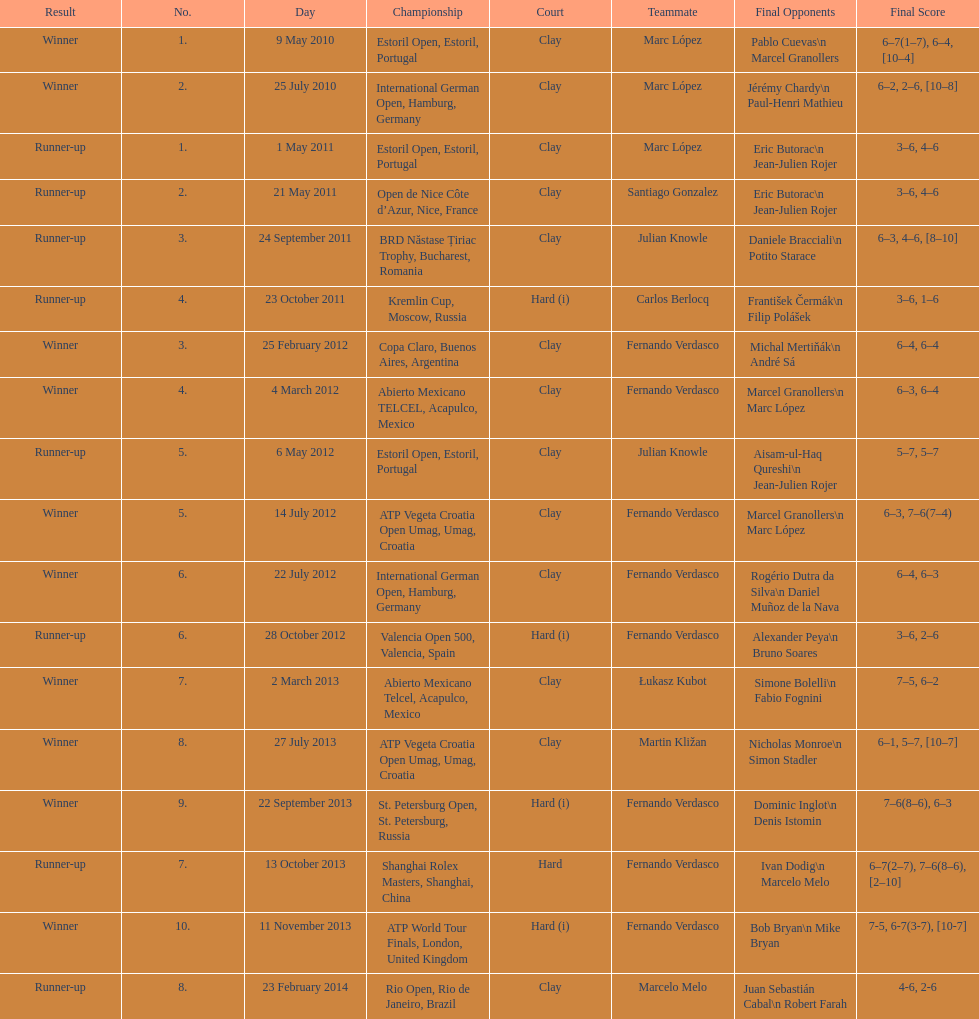How many runner-ups at most are listed? 8. Would you be able to parse every entry in this table? {'header': ['Result', 'No.', 'Day', 'Championship', 'Court', 'Teammate', 'Final Opponents', 'Final Score'], 'rows': [['Winner', '1.', '9 May 2010', 'Estoril Open, Estoril, Portugal', 'Clay', 'Marc López', 'Pablo Cuevas\\n Marcel Granollers', '6–7(1–7), 6–4, [10–4]'], ['Winner', '2.', '25 July 2010', 'International German Open, Hamburg, Germany', 'Clay', 'Marc López', 'Jérémy Chardy\\n Paul-Henri Mathieu', '6–2, 2–6, [10–8]'], ['Runner-up', '1.', '1 May 2011', 'Estoril Open, Estoril, Portugal', 'Clay', 'Marc López', 'Eric Butorac\\n Jean-Julien Rojer', '3–6, 4–6'], ['Runner-up', '2.', '21 May 2011', 'Open de Nice Côte d’Azur, Nice, France', 'Clay', 'Santiago Gonzalez', 'Eric Butorac\\n Jean-Julien Rojer', '3–6, 4–6'], ['Runner-up', '3.', '24 September 2011', 'BRD Năstase Țiriac Trophy, Bucharest, Romania', 'Clay', 'Julian Knowle', 'Daniele Bracciali\\n Potito Starace', '6–3, 4–6, [8–10]'], ['Runner-up', '4.', '23 October 2011', 'Kremlin Cup, Moscow, Russia', 'Hard (i)', 'Carlos Berlocq', 'František Čermák\\n Filip Polášek', '3–6, 1–6'], ['Winner', '3.', '25 February 2012', 'Copa Claro, Buenos Aires, Argentina', 'Clay', 'Fernando Verdasco', 'Michal Mertiňák\\n André Sá', '6–4, 6–4'], ['Winner', '4.', '4 March 2012', 'Abierto Mexicano TELCEL, Acapulco, Mexico', 'Clay', 'Fernando Verdasco', 'Marcel Granollers\\n Marc López', '6–3, 6–4'], ['Runner-up', '5.', '6 May 2012', 'Estoril Open, Estoril, Portugal', 'Clay', 'Julian Knowle', 'Aisam-ul-Haq Qureshi\\n Jean-Julien Rojer', '5–7, 5–7'], ['Winner', '5.', '14 July 2012', 'ATP Vegeta Croatia Open Umag, Umag, Croatia', 'Clay', 'Fernando Verdasco', 'Marcel Granollers\\n Marc López', '6–3, 7–6(7–4)'], ['Winner', '6.', '22 July 2012', 'International German Open, Hamburg, Germany', 'Clay', 'Fernando Verdasco', 'Rogério Dutra da Silva\\n Daniel Muñoz de la Nava', '6–4, 6–3'], ['Runner-up', '6.', '28 October 2012', 'Valencia Open 500, Valencia, Spain', 'Hard (i)', 'Fernando Verdasco', 'Alexander Peya\\n Bruno Soares', '3–6, 2–6'], ['Winner', '7.', '2 March 2013', 'Abierto Mexicano Telcel, Acapulco, Mexico', 'Clay', 'Łukasz Kubot', 'Simone Bolelli\\n Fabio Fognini', '7–5, 6–2'], ['Winner', '8.', '27 July 2013', 'ATP Vegeta Croatia Open Umag, Umag, Croatia', 'Clay', 'Martin Kližan', 'Nicholas Monroe\\n Simon Stadler', '6–1, 5–7, [10–7]'], ['Winner', '9.', '22 September 2013', 'St. Petersburg Open, St. Petersburg, Russia', 'Hard (i)', 'Fernando Verdasco', 'Dominic Inglot\\n Denis Istomin', '7–6(8–6), 6–3'], ['Runner-up', '7.', '13 October 2013', 'Shanghai Rolex Masters, Shanghai, China', 'Hard', 'Fernando Verdasco', 'Ivan Dodig\\n Marcelo Melo', '6–7(2–7), 7–6(8–6), [2–10]'], ['Winner', '10.', '11 November 2013', 'ATP World Tour Finals, London, United Kingdom', 'Hard (i)', 'Fernando Verdasco', 'Bob Bryan\\n Mike Bryan', '7-5, 6-7(3-7), [10-7]'], ['Runner-up', '8.', '23 February 2014', 'Rio Open, Rio de Janeiro, Brazil', 'Clay', 'Marcelo Melo', 'Juan Sebastián Cabal\\n Robert Farah', '4-6, 2-6']]} 